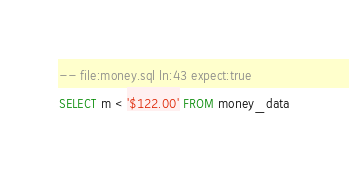<code> <loc_0><loc_0><loc_500><loc_500><_SQL_>-- file:money.sql ln:43 expect:true
SELECT m < '$122.00' FROM money_data
</code> 